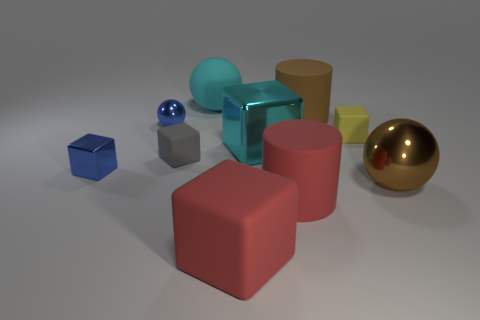There is a big ball that is the same color as the large metallic cube; what is it made of?
Give a very brief answer. Rubber. Are there more big cyan objects that are left of the yellow object than small blue metallic spheres?
Offer a terse response. Yes. There is a brown cylinder that is the same size as the cyan rubber sphere; what is its material?
Offer a terse response. Rubber. Is there another brown thing of the same size as the brown metallic thing?
Ensure brevity in your answer.  Yes. What size is the blue object that is behind the small yellow thing?
Make the answer very short. Small. The brown metal object is what size?
Your response must be concise. Large. How many cubes are either rubber objects or tiny metal objects?
Provide a succinct answer. 4. There is a blue cube that is made of the same material as the blue ball; what size is it?
Offer a terse response. Small. How many matte cubes are the same color as the large rubber ball?
Provide a short and direct response. 0. There is a brown ball; are there any large brown objects to the left of it?
Provide a short and direct response. Yes. 